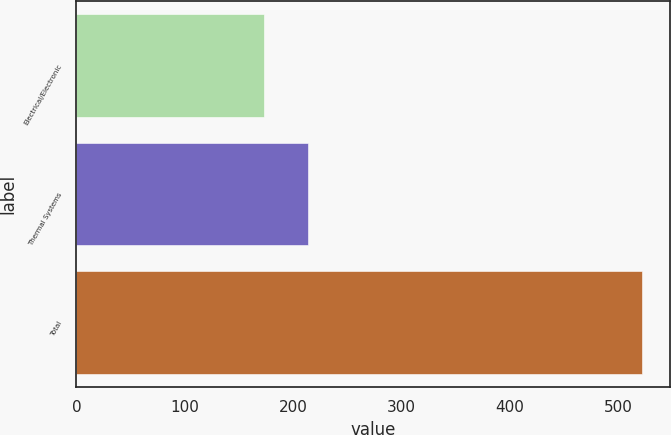<chart> <loc_0><loc_0><loc_500><loc_500><bar_chart><fcel>Electrical/Electronic<fcel>Thermal Systems<fcel>Total<nl><fcel>173<fcel>214<fcel>522<nl></chart> 